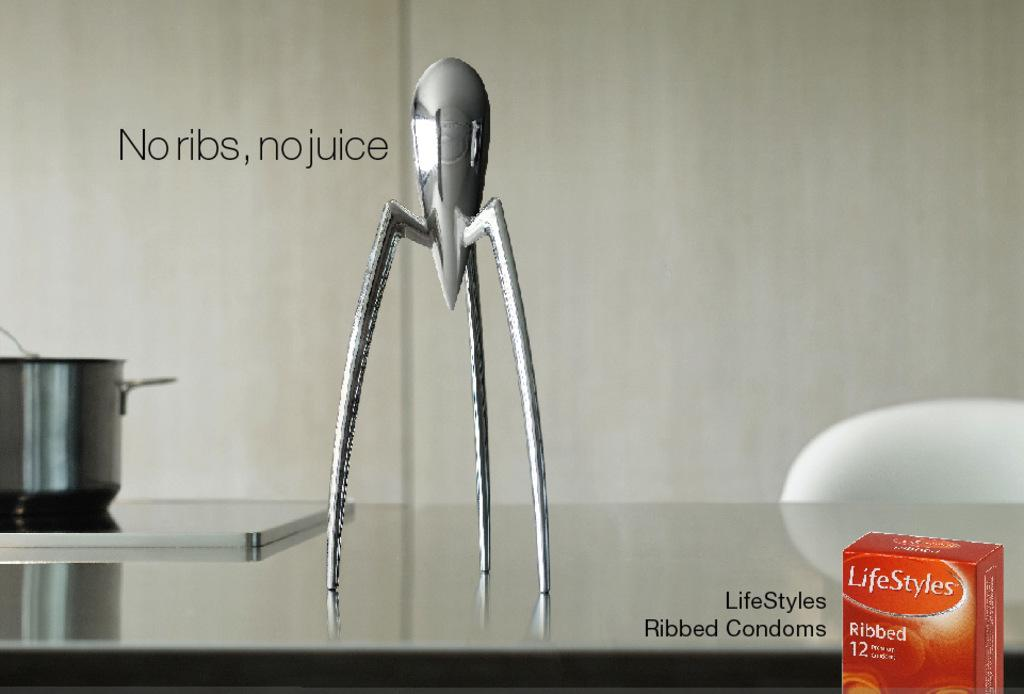<image>
Write a terse but informative summary of the picture. A metal device in on a counter with the words No ribs, no juice captioned beside it 